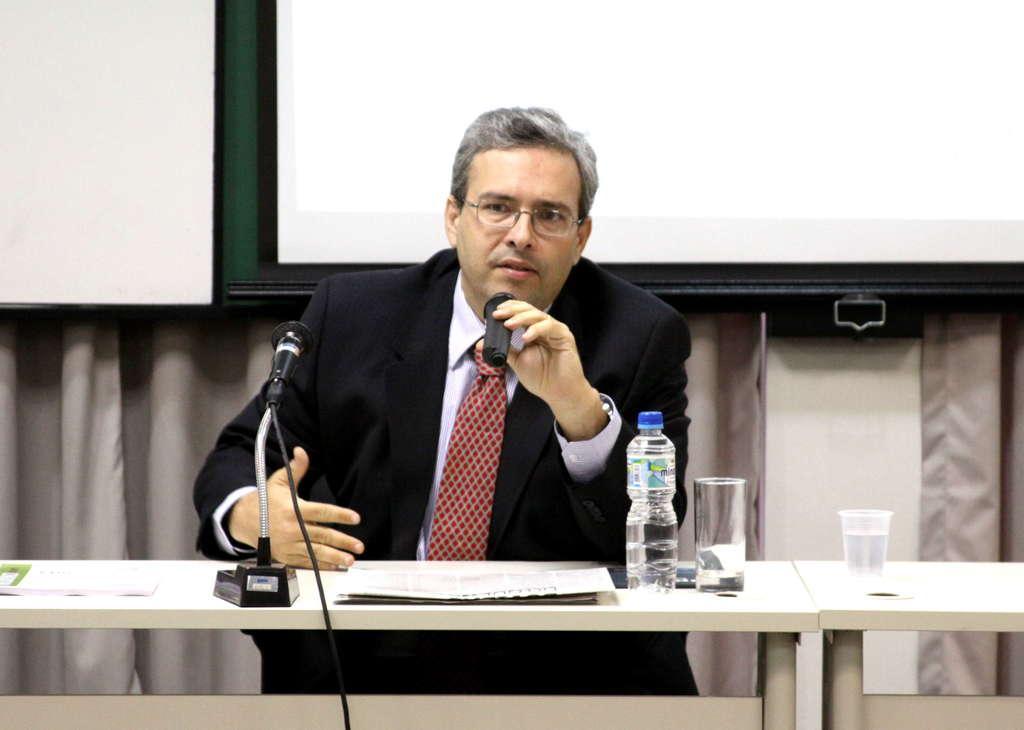Can you describe this image briefly? In this picture we can see man sitting on chair and talking on mic and in front of him there is table and on table we can see bottle, glass, paper, mic and in background we can see screen. 